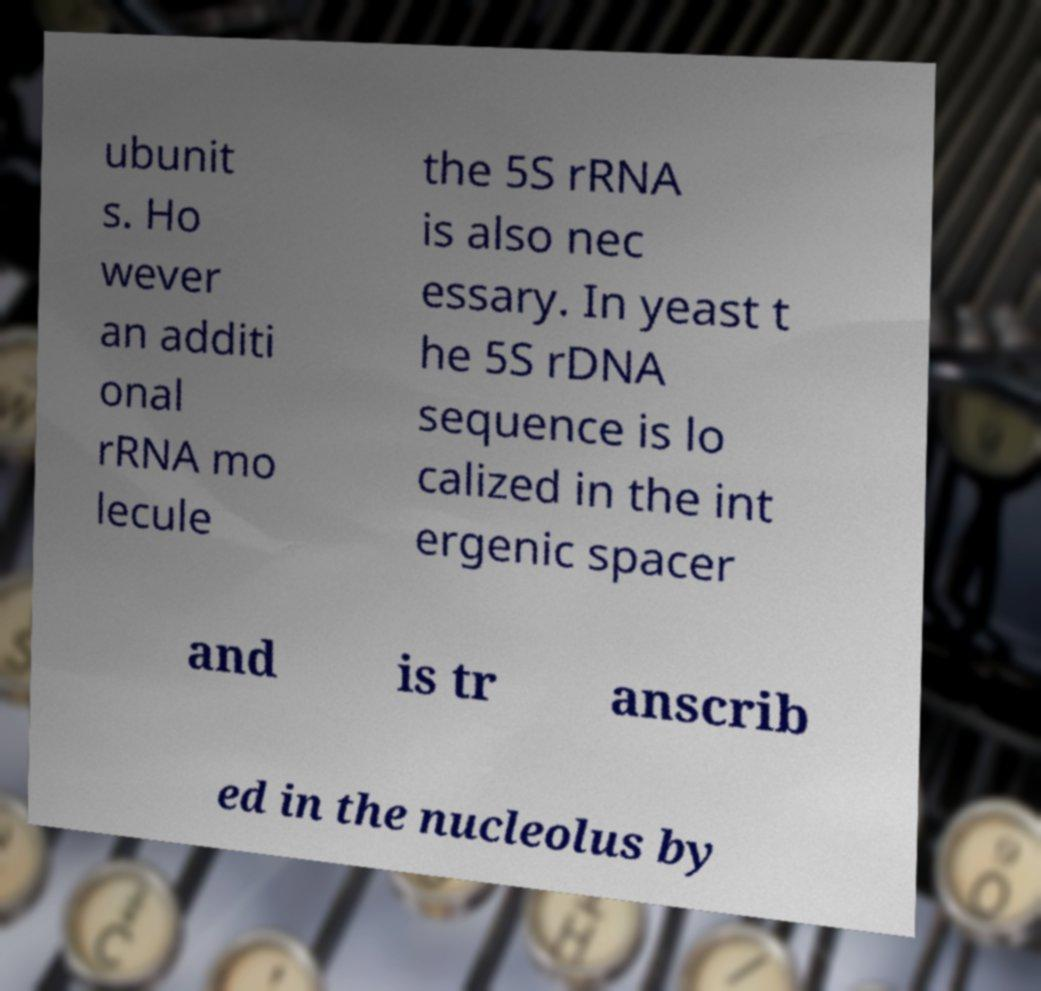Please identify and transcribe the text found in this image. ubunit s. Ho wever an additi onal rRNA mo lecule the 5S rRNA is also nec essary. In yeast t he 5S rDNA sequence is lo calized in the int ergenic spacer and is tr anscrib ed in the nucleolus by 